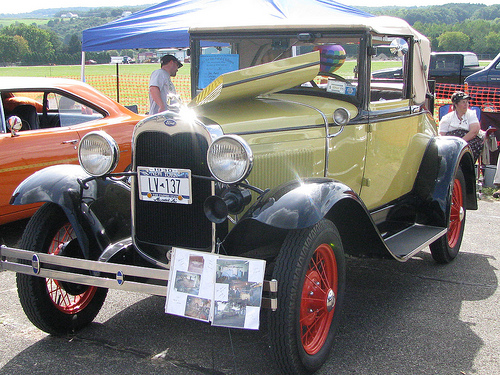<image>
Is there a photo in front of the car? Yes. The photo is positioned in front of the car, appearing closer to the camera viewpoint. 